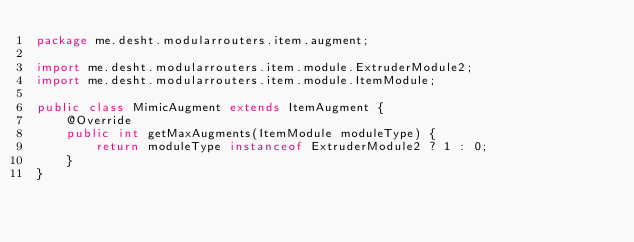<code> <loc_0><loc_0><loc_500><loc_500><_Java_>package me.desht.modularrouters.item.augment;

import me.desht.modularrouters.item.module.ExtruderModule2;
import me.desht.modularrouters.item.module.ItemModule;

public class MimicAugment extends ItemAugment {
    @Override
    public int getMaxAugments(ItemModule moduleType) {
        return moduleType instanceof ExtruderModule2 ? 1 : 0;
    }
}
</code> 